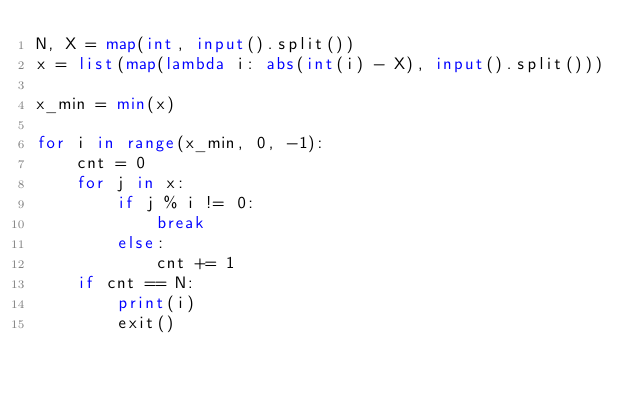<code> <loc_0><loc_0><loc_500><loc_500><_Python_>N, X = map(int, input().split())
x = list(map(lambda i: abs(int(i) - X), input().split()))

x_min = min(x)

for i in range(x_min, 0, -1):
    cnt = 0
    for j in x:
        if j % i != 0:
            break
        else:
            cnt += 1
    if cnt == N:
        print(i)
        exit()</code> 